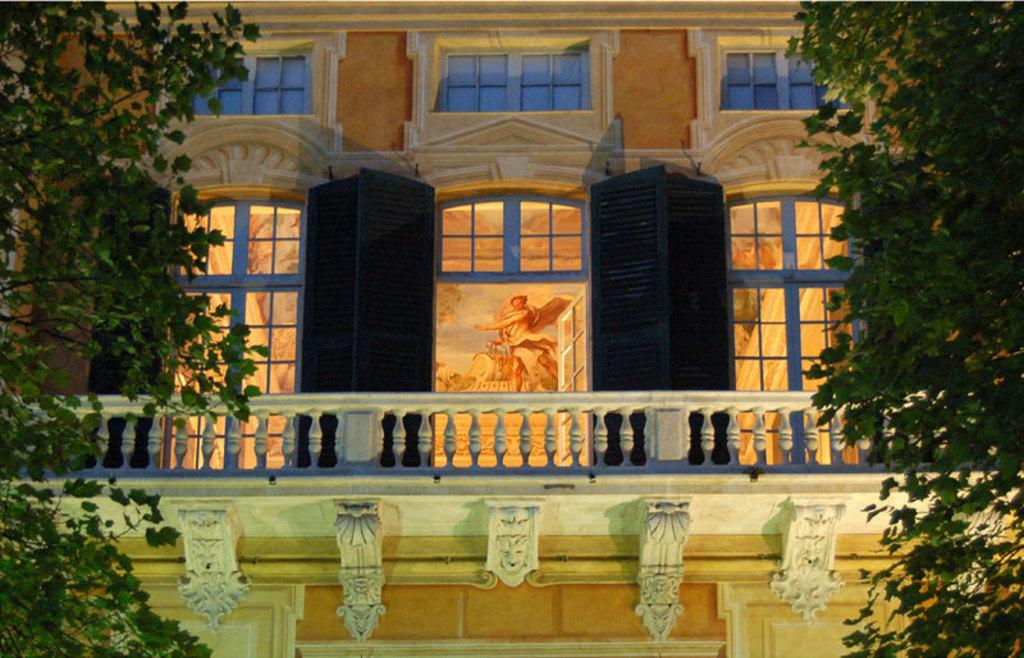What type of vegetation is present on both sides of the image? There are trees on both sides of the image. What type of structure can be seen in the background of the image? There is a building in the background of the image. How many black objects are visible in the image? There are two black objects in the image. Where is the cave located in the image? There is no cave present in the image. What type of furniture can be seen in the bedroom in the image? There is no bedroom present in the image. 